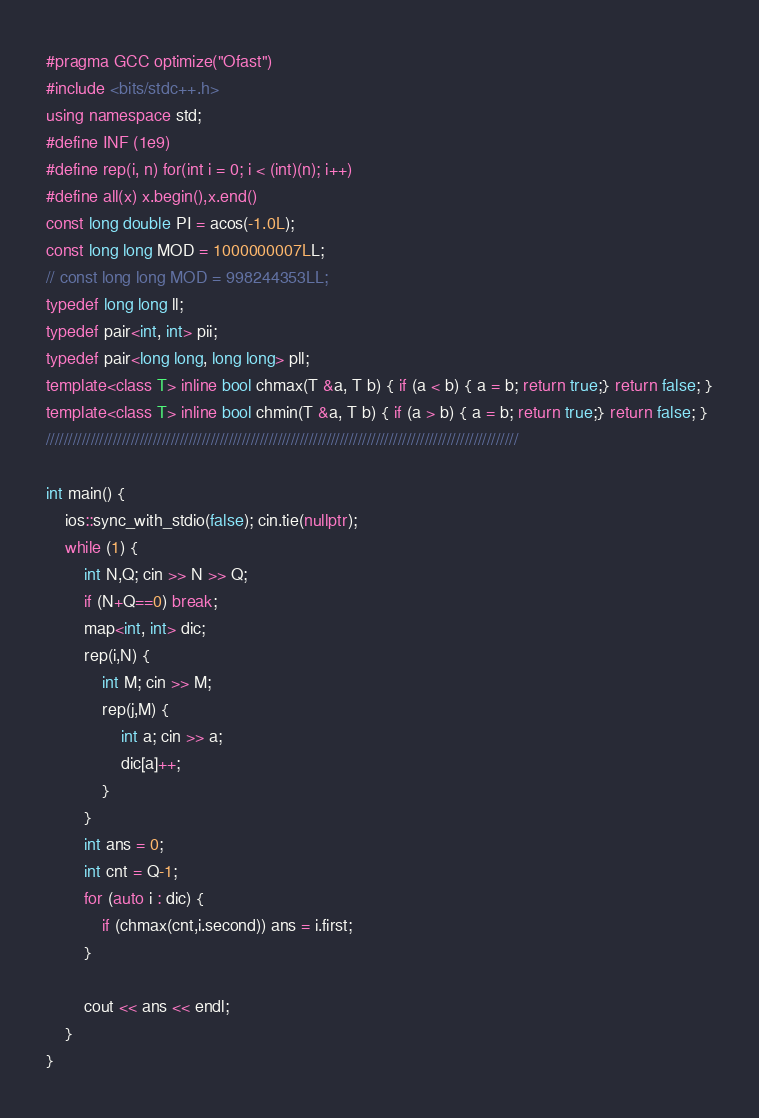<code> <loc_0><loc_0><loc_500><loc_500><_C++_>#pragma GCC optimize("Ofast")
#include <bits/stdc++.h>
using namespace std;
#define INF (1e9)
#define rep(i, n) for(int i = 0; i < (int)(n); i++)
#define all(x) x.begin(),x.end()
const long double PI = acos(-1.0L);
const long long MOD = 1000000007LL;
// const long long MOD = 998244353LL;
typedef long long ll;
typedef pair<int, int> pii;
typedef pair<long long, long long> pll;
template<class T> inline bool chmax(T &a, T b) { if (a < b) { a = b; return true;} return false; }
template<class T> inline bool chmin(T &a, T b) { if (a > b) { a = b; return true;} return false; }
//////////////////////////////////////////////////////////////////////////////////////////////////////////

int main() {
    ios::sync_with_stdio(false); cin.tie(nullptr);
    while (1) {
        int N,Q; cin >> N >> Q;
        if (N+Q==0) break;
        map<int, int> dic;
        rep(i,N) {
            int M; cin >> M;
            rep(j,M) {
                int a; cin >> a;
                dic[a]++;
            }
        }
        int ans = 0;
        int cnt = Q-1;
        for (auto i : dic) {
            if (chmax(cnt,i.second)) ans = i.first;
        }

        cout << ans << endl;
    }
}
</code> 